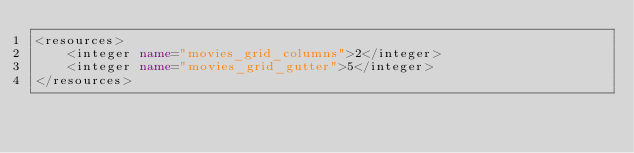<code> <loc_0><loc_0><loc_500><loc_500><_XML_><resources>
    <integer name="movies_grid_columns">2</integer>
    <integer name="movies_grid_gutter">5</integer>
</resources></code> 